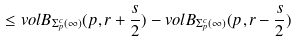Convert formula to latex. <formula><loc_0><loc_0><loc_500><loc_500>\leq v o l B _ { \Sigma _ { p } ^ { c } ( \infty ) } ( p , r + \frac { s } { 2 } ) - v o l B _ { \Sigma _ { p } ^ { c } ( \infty ) } ( p , r - \frac { s } { 2 } )</formula> 